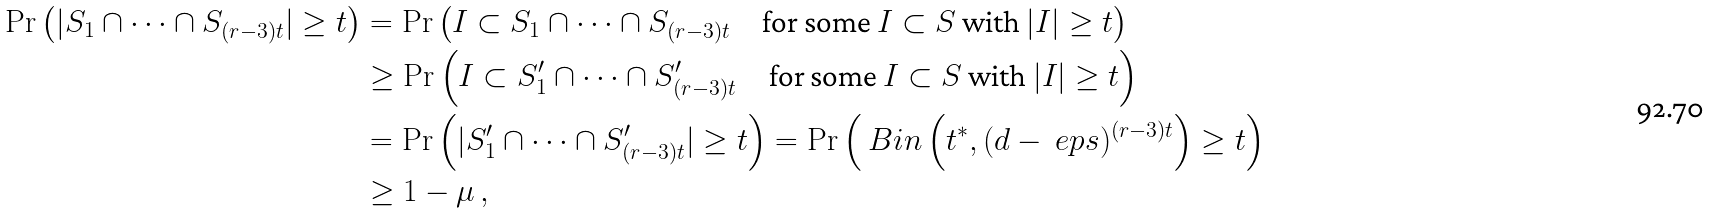Convert formula to latex. <formula><loc_0><loc_0><loc_500><loc_500>\Pr \left ( | S _ { 1 } \cap \dots \cap S _ { ( r - 3 ) t } | \geq t \right ) & = \Pr \left ( I \subset S _ { 1 } \cap \dots \cap S _ { ( r - 3 ) t } \quad \text {for    some $I\subset S$ with $|I|\geq t$} \right ) \\ & \geq \Pr \left ( I \subset S ^ { \prime } _ { 1 } \cap \dots \cap S ^ { \prime } _ { ( r - 3 ) t } \quad \text {for    some $I\subset S$ with $|I|\geq t$} \right ) \\ & = \Pr \left ( | S ^ { \prime } _ { 1 } \cap \dots \cap S ^ { \prime } _ { ( r - 3 ) t } | \geq t \right ) = \Pr \left ( \ B i n \left ( t ^ { * } , ( d - \ e p s ) ^ { ( r - 3 ) t } \right ) \geq t \right ) \\ & \geq 1 - \mu \, ,</formula> 